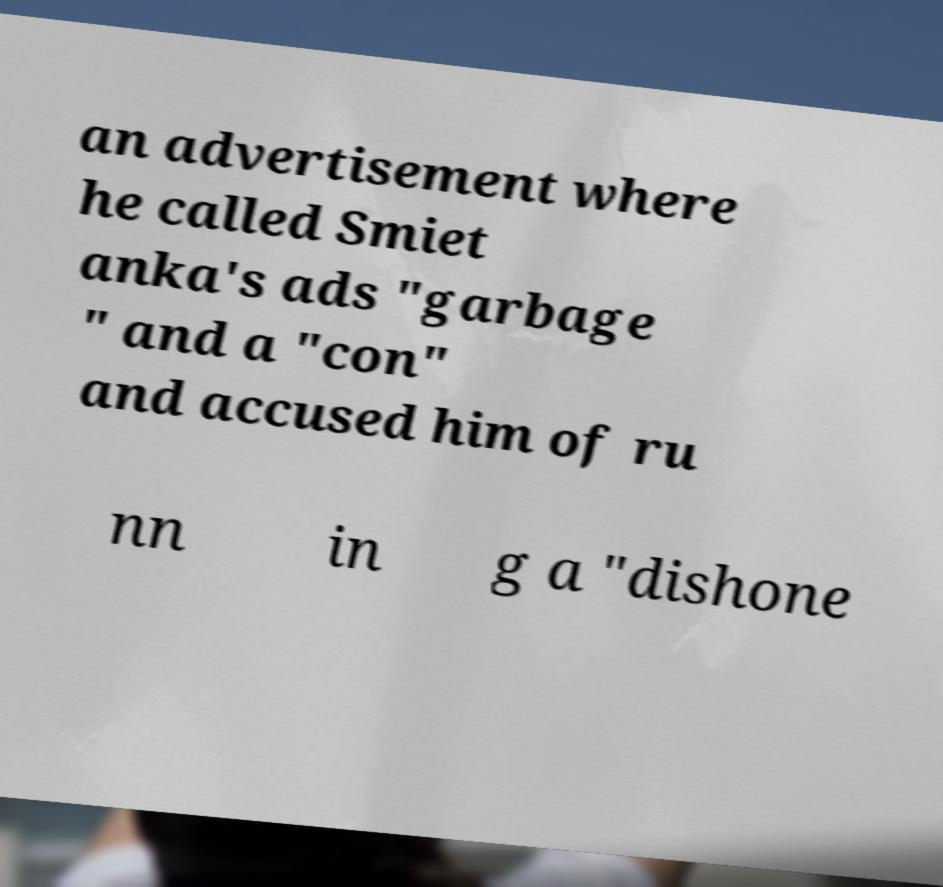Please read and relay the text visible in this image. What does it say? an advertisement where he called Smiet anka's ads "garbage " and a "con" and accused him of ru nn in g a "dishone 